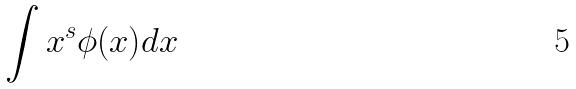<formula> <loc_0><loc_0><loc_500><loc_500>\int x ^ { s } \phi ( x ) d x</formula> 